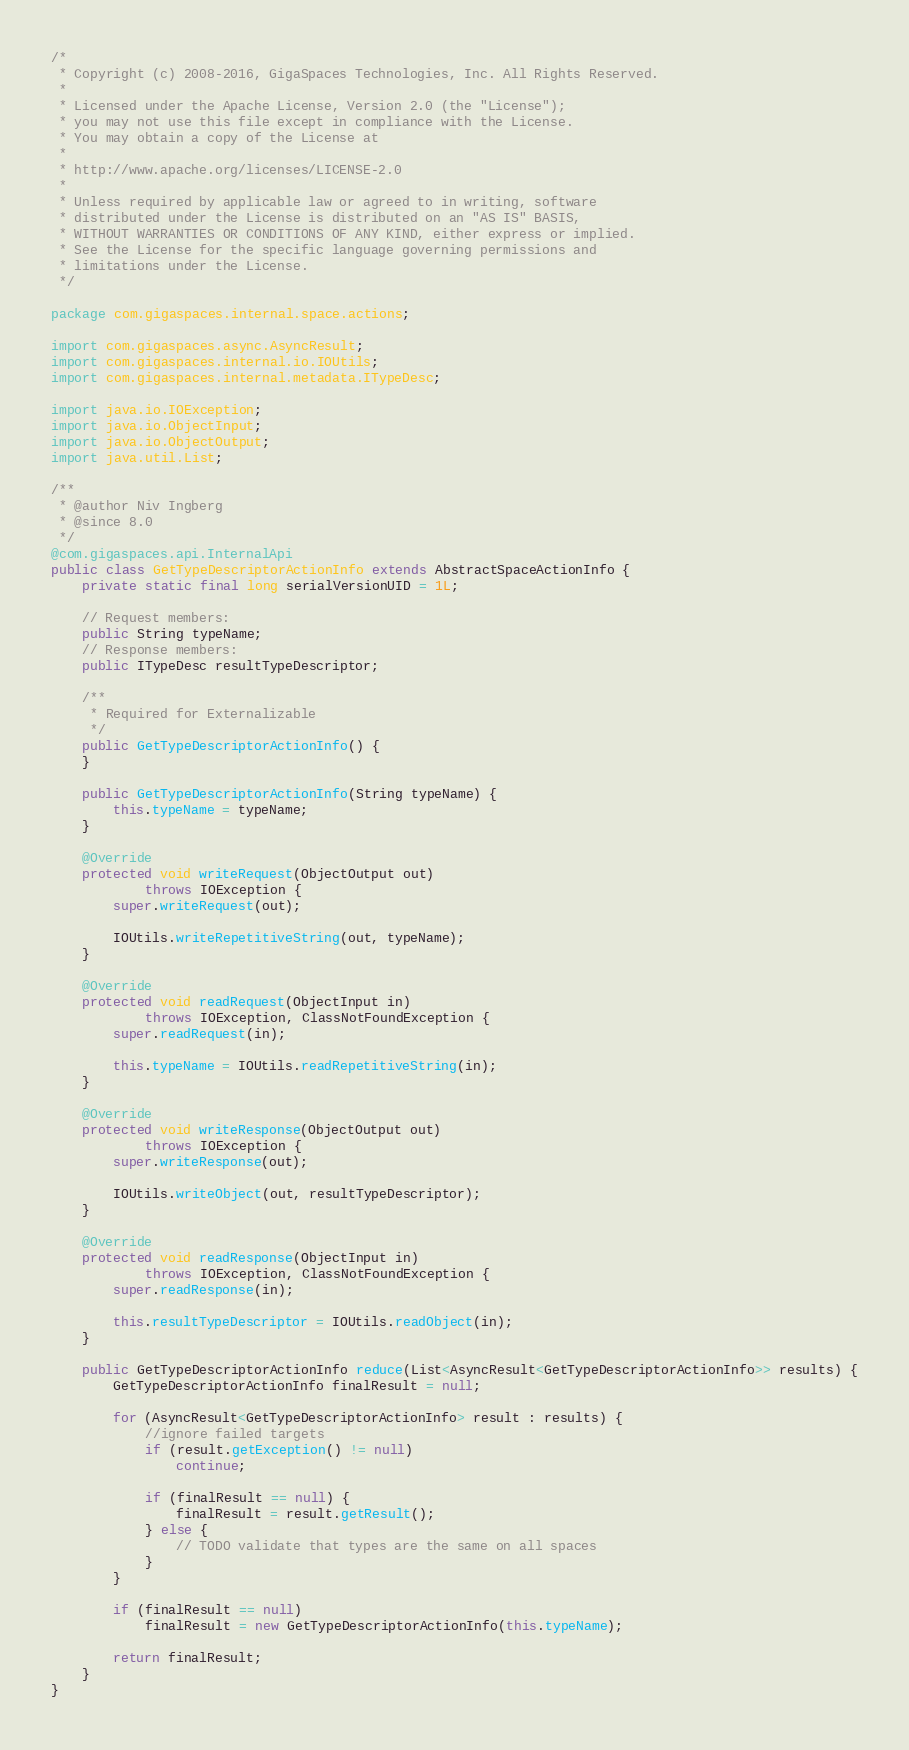Convert code to text. <code><loc_0><loc_0><loc_500><loc_500><_Java_>/*
 * Copyright (c) 2008-2016, GigaSpaces Technologies, Inc. All Rights Reserved.
 *
 * Licensed under the Apache License, Version 2.0 (the "License");
 * you may not use this file except in compliance with the License.
 * You may obtain a copy of the License at
 *
 * http://www.apache.org/licenses/LICENSE-2.0
 *
 * Unless required by applicable law or agreed to in writing, software
 * distributed under the License is distributed on an "AS IS" BASIS,
 * WITHOUT WARRANTIES OR CONDITIONS OF ANY KIND, either express or implied.
 * See the License for the specific language governing permissions and
 * limitations under the License.
 */

package com.gigaspaces.internal.space.actions;

import com.gigaspaces.async.AsyncResult;
import com.gigaspaces.internal.io.IOUtils;
import com.gigaspaces.internal.metadata.ITypeDesc;

import java.io.IOException;
import java.io.ObjectInput;
import java.io.ObjectOutput;
import java.util.List;

/**
 * @author Niv Ingberg
 * @since 8.0
 */
@com.gigaspaces.api.InternalApi
public class GetTypeDescriptorActionInfo extends AbstractSpaceActionInfo {
    private static final long serialVersionUID = 1L;

    // Request members:
    public String typeName;
    // Response members:
    public ITypeDesc resultTypeDescriptor;

    /**
     * Required for Externalizable
     */
    public GetTypeDescriptorActionInfo() {
    }

    public GetTypeDescriptorActionInfo(String typeName) {
        this.typeName = typeName;
    }

    @Override
    protected void writeRequest(ObjectOutput out)
            throws IOException {
        super.writeRequest(out);

        IOUtils.writeRepetitiveString(out, typeName);
    }

    @Override
    protected void readRequest(ObjectInput in)
            throws IOException, ClassNotFoundException {
        super.readRequest(in);

        this.typeName = IOUtils.readRepetitiveString(in);
    }

    @Override
    protected void writeResponse(ObjectOutput out)
            throws IOException {
        super.writeResponse(out);

        IOUtils.writeObject(out, resultTypeDescriptor);
    }

    @Override
    protected void readResponse(ObjectInput in)
            throws IOException, ClassNotFoundException {
        super.readResponse(in);

        this.resultTypeDescriptor = IOUtils.readObject(in);
    }

    public GetTypeDescriptorActionInfo reduce(List<AsyncResult<GetTypeDescriptorActionInfo>> results) {
        GetTypeDescriptorActionInfo finalResult = null;

        for (AsyncResult<GetTypeDescriptorActionInfo> result : results) {
            //ignore failed targets
            if (result.getException() != null)
                continue;

            if (finalResult == null) {
                finalResult = result.getResult();
            } else {
                // TODO validate that types are the same on all spaces
            }
        }

        if (finalResult == null)
            finalResult = new GetTypeDescriptorActionInfo(this.typeName);

        return finalResult;
    }
}
</code> 